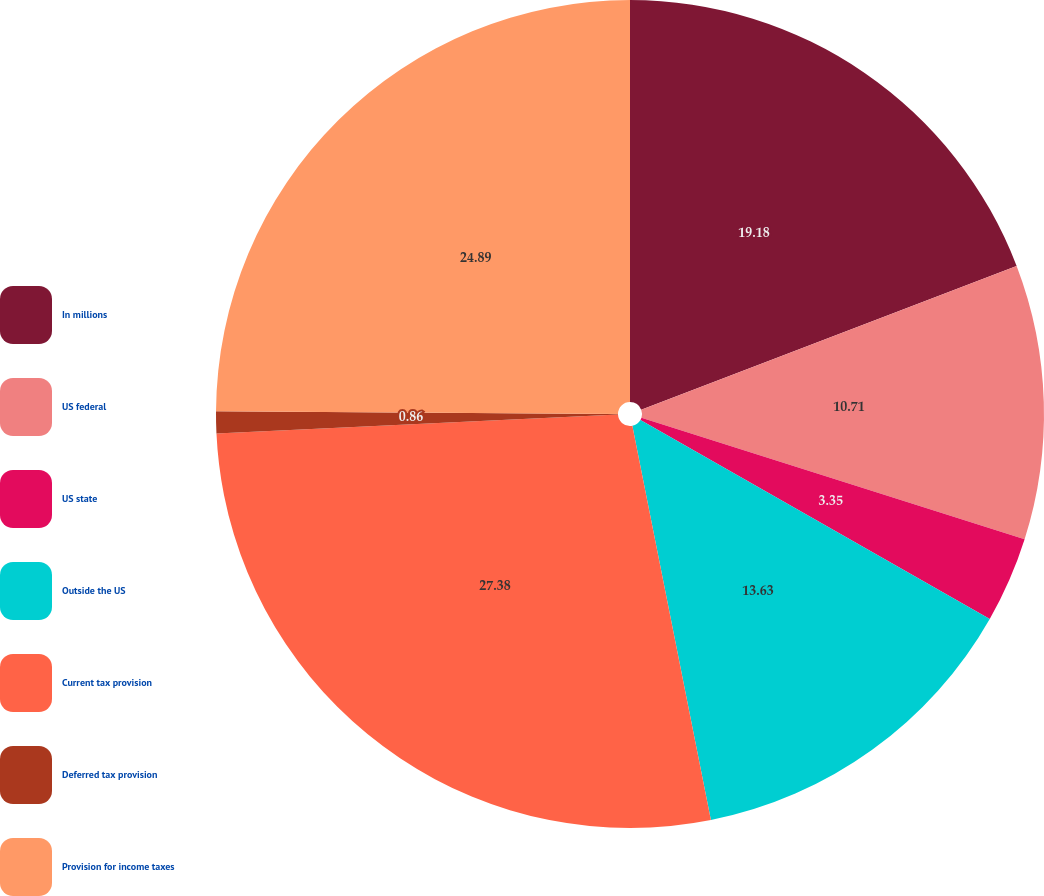<chart> <loc_0><loc_0><loc_500><loc_500><pie_chart><fcel>In millions<fcel>US federal<fcel>US state<fcel>Outside the US<fcel>Current tax provision<fcel>Deferred tax provision<fcel>Provision for income taxes<nl><fcel>19.18%<fcel>10.71%<fcel>3.35%<fcel>13.63%<fcel>27.38%<fcel>0.86%<fcel>24.89%<nl></chart> 